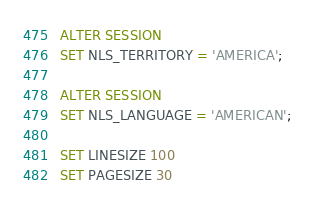Convert code to text. <code><loc_0><loc_0><loc_500><loc_500><_SQL_>ALTER SESSION
SET NLS_TERRITORY = 'AMERICA';

ALTER SESSION
SET NLS_LANGUAGE = 'AMERICAN';

SET LINESIZE 100
SET PAGESIZE 30

</code> 